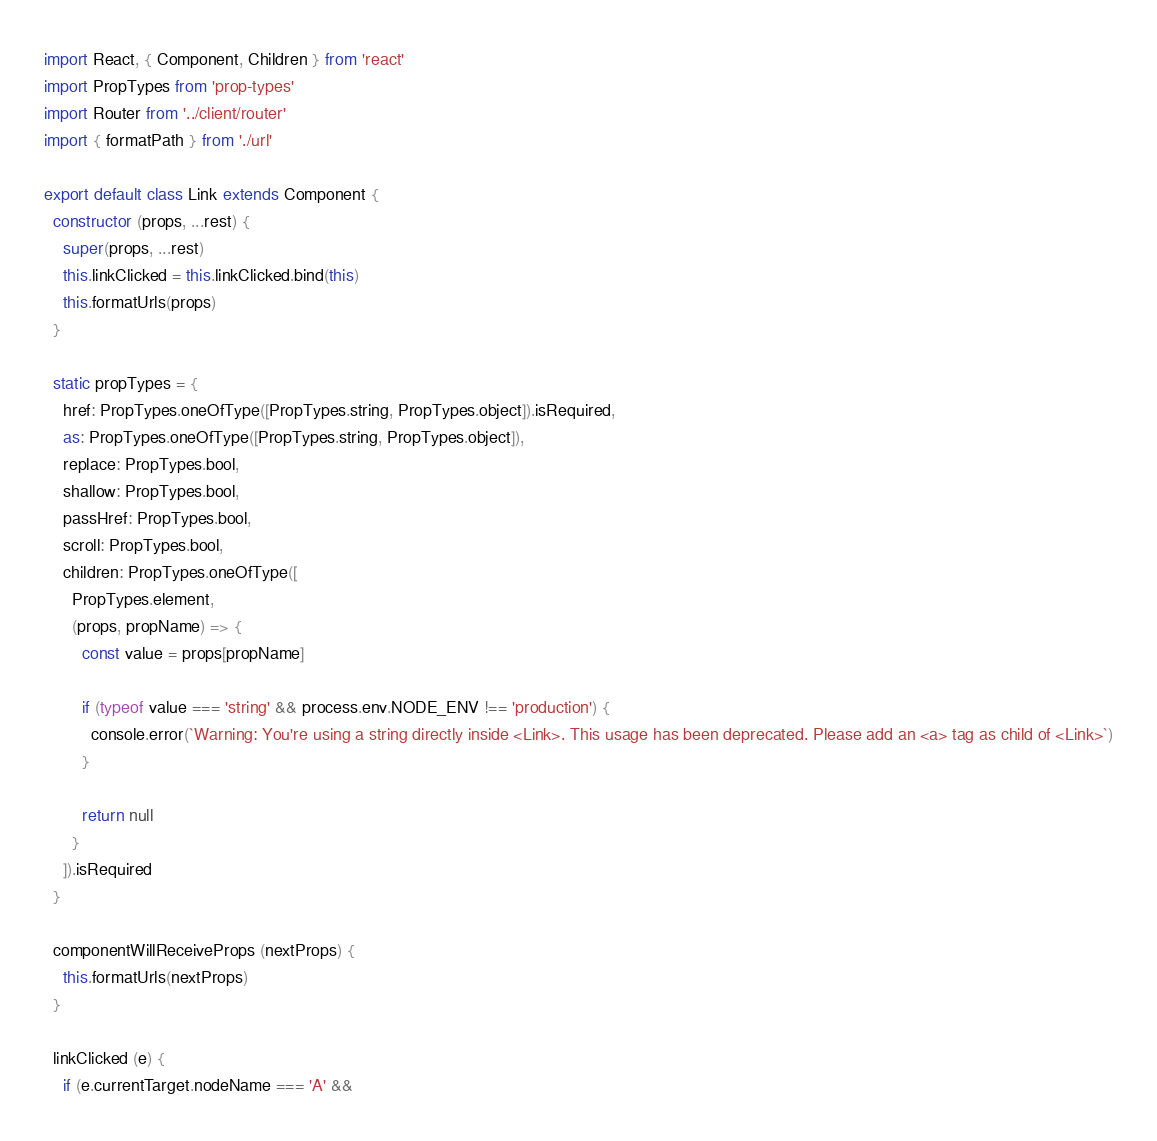Convert code to text. <code><loc_0><loc_0><loc_500><loc_500><_JavaScript_>import React, { Component, Children } from 'react'
import PropTypes from 'prop-types'
import Router from '../client/router'
import { formatPath } from './url'

export default class Link extends Component {
  constructor (props, ...rest) {
    super(props, ...rest)
    this.linkClicked = this.linkClicked.bind(this)
    this.formatUrls(props)
  }

  static propTypes = {
    href: PropTypes.oneOfType([PropTypes.string, PropTypes.object]).isRequired,
    as: PropTypes.oneOfType([PropTypes.string, PropTypes.object]),
    replace: PropTypes.bool,
    shallow: PropTypes.bool,
    passHref: PropTypes.bool,
    scroll: PropTypes.bool,
    children: PropTypes.oneOfType([
      PropTypes.element,
      (props, propName) => {
        const value = props[propName]

        if (typeof value === 'string' && process.env.NODE_ENV !== 'production') {
          console.error(`Warning: You're using a string directly inside <Link>. This usage has been deprecated. Please add an <a> tag as child of <Link>`)
        }

        return null
      }
    ]).isRequired
  }

  componentWillReceiveProps (nextProps) {
    this.formatUrls(nextProps)
  }

  linkClicked (e) {
    if (e.currentTarget.nodeName === 'A' &&</code> 